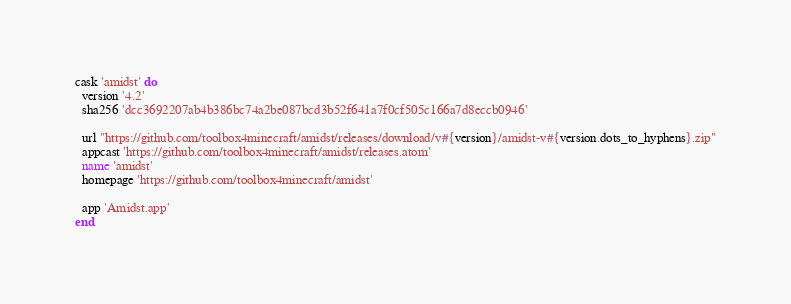<code> <loc_0><loc_0><loc_500><loc_500><_Ruby_>cask 'amidst' do
  version '4.2'
  sha256 'dcc3692207ab4b386bc74a2be087bcd3b52f641a7f0cf505c166a7d8eccb0946'

  url "https://github.com/toolbox4minecraft/amidst/releases/download/v#{version}/amidst-v#{version.dots_to_hyphens}.zip"
  appcast 'https://github.com/toolbox4minecraft/amidst/releases.atom'
  name 'amidst'
  homepage 'https://github.com/toolbox4minecraft/amidst'

  app 'Amidst.app'
end
</code> 